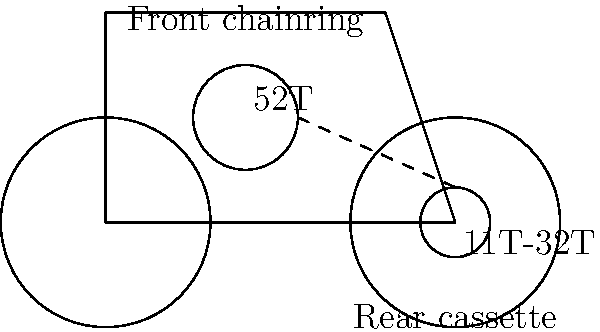As an athlete familiar with cycling, you understand the importance of gear ratios in performance. Given a bicycle with a 52-tooth front chainring and a rear cassette ranging from 11 to 32 teeth, what is the gear ratio range, and how does it affect the cyclist's performance in different terrains? To solve this problem, let's follow these steps:

1. Calculate the highest gear ratio:
   Highest ratio = Largest front / Smallest rear
   $$ \text{Highest ratio} = \frac{52}{11} \approx 4.73 $$

2. Calculate the lowest gear ratio:
   Lowest ratio = Largest front / Largest rear
   $$ \text{Lowest ratio} = \frac{52}{32} \approx 1.63 $$

3. Determine the gear ratio range:
   Range = Highest ratio - Lowest ratio
   $$ \text{Range} = 4.73 - 1.63 = 3.10 $$

4. Interpret the results:
   - The highest gear ratio (4.73) is suitable for high-speed riding on flat terrain or downhill sections. It allows for greater speed with each pedal revolution.
   - The lowest gear ratio (1.63) is ideal for climbing steep hills or riding in challenging terrain. It provides more torque and makes pedaling easier in these conditions.
   - The wide range (3.10) offers versatility, allowing the cyclist to efficiently tackle various terrains and riding conditions.

5. Performance effects:
   - Higher ratios enable faster speeds on flat ground and descents.
   - Lower ratios facilitate easier pedaling and maintain momentum on climbs.
   - The wide range allows for optimal cadence maintenance across different terrains, potentially improving overall performance and reducing fatigue.
Answer: Gear ratio range: 1.63 to 4.73. Higher ratios for speed, lower for climbing; wide range improves versatility and performance across terrains. 